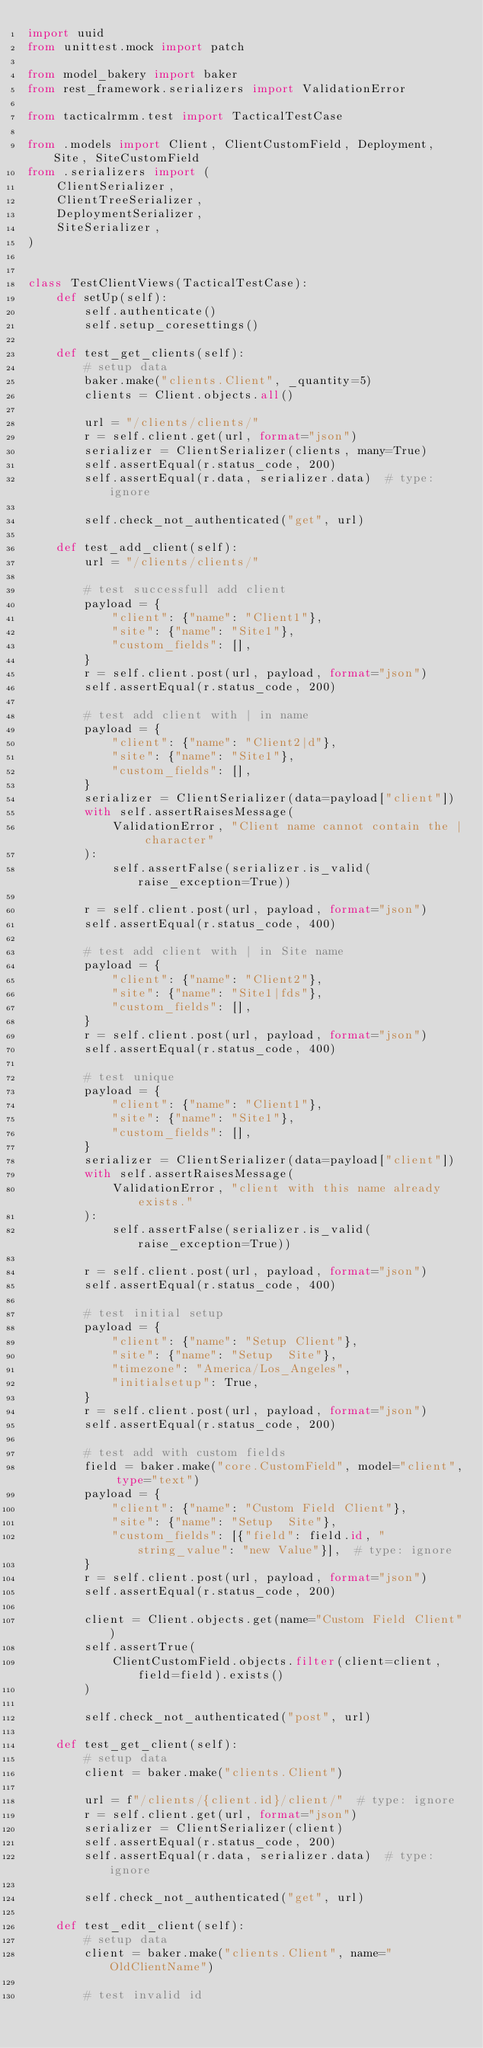<code> <loc_0><loc_0><loc_500><loc_500><_Python_>import uuid
from unittest.mock import patch

from model_bakery import baker
from rest_framework.serializers import ValidationError

from tacticalrmm.test import TacticalTestCase

from .models import Client, ClientCustomField, Deployment, Site, SiteCustomField
from .serializers import (
    ClientSerializer,
    ClientTreeSerializer,
    DeploymentSerializer,
    SiteSerializer,
)


class TestClientViews(TacticalTestCase):
    def setUp(self):
        self.authenticate()
        self.setup_coresettings()

    def test_get_clients(self):
        # setup data
        baker.make("clients.Client", _quantity=5)
        clients = Client.objects.all()

        url = "/clients/clients/"
        r = self.client.get(url, format="json")
        serializer = ClientSerializer(clients, many=True)
        self.assertEqual(r.status_code, 200)
        self.assertEqual(r.data, serializer.data)  # type: ignore

        self.check_not_authenticated("get", url)

    def test_add_client(self):
        url = "/clients/clients/"

        # test successfull add client
        payload = {
            "client": {"name": "Client1"},
            "site": {"name": "Site1"},
            "custom_fields": [],
        }
        r = self.client.post(url, payload, format="json")
        self.assertEqual(r.status_code, 200)

        # test add client with | in name
        payload = {
            "client": {"name": "Client2|d"},
            "site": {"name": "Site1"},
            "custom_fields": [],
        }
        serializer = ClientSerializer(data=payload["client"])
        with self.assertRaisesMessage(
            ValidationError, "Client name cannot contain the | character"
        ):
            self.assertFalse(serializer.is_valid(raise_exception=True))

        r = self.client.post(url, payload, format="json")
        self.assertEqual(r.status_code, 400)

        # test add client with | in Site name
        payload = {
            "client": {"name": "Client2"},
            "site": {"name": "Site1|fds"},
            "custom_fields": [],
        }
        r = self.client.post(url, payload, format="json")
        self.assertEqual(r.status_code, 400)

        # test unique
        payload = {
            "client": {"name": "Client1"},
            "site": {"name": "Site1"},
            "custom_fields": [],
        }
        serializer = ClientSerializer(data=payload["client"])
        with self.assertRaisesMessage(
            ValidationError, "client with this name already exists."
        ):
            self.assertFalse(serializer.is_valid(raise_exception=True))

        r = self.client.post(url, payload, format="json")
        self.assertEqual(r.status_code, 400)

        # test initial setup
        payload = {
            "client": {"name": "Setup Client"},
            "site": {"name": "Setup  Site"},
            "timezone": "America/Los_Angeles",
            "initialsetup": True,
        }
        r = self.client.post(url, payload, format="json")
        self.assertEqual(r.status_code, 200)

        # test add with custom fields
        field = baker.make("core.CustomField", model="client", type="text")
        payload = {
            "client": {"name": "Custom Field Client"},
            "site": {"name": "Setup  Site"},
            "custom_fields": [{"field": field.id, "string_value": "new Value"}],  # type: ignore
        }
        r = self.client.post(url, payload, format="json")
        self.assertEqual(r.status_code, 200)

        client = Client.objects.get(name="Custom Field Client")
        self.assertTrue(
            ClientCustomField.objects.filter(client=client, field=field).exists()
        )

        self.check_not_authenticated("post", url)

    def test_get_client(self):
        # setup data
        client = baker.make("clients.Client")

        url = f"/clients/{client.id}/client/"  # type: ignore
        r = self.client.get(url, format="json")
        serializer = ClientSerializer(client)
        self.assertEqual(r.status_code, 200)
        self.assertEqual(r.data, serializer.data)  # type: ignore

        self.check_not_authenticated("get", url)

    def test_edit_client(self):
        # setup data
        client = baker.make("clients.Client", name="OldClientName")

        # test invalid id</code> 